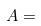<formula> <loc_0><loc_0><loc_500><loc_500>A =</formula> 